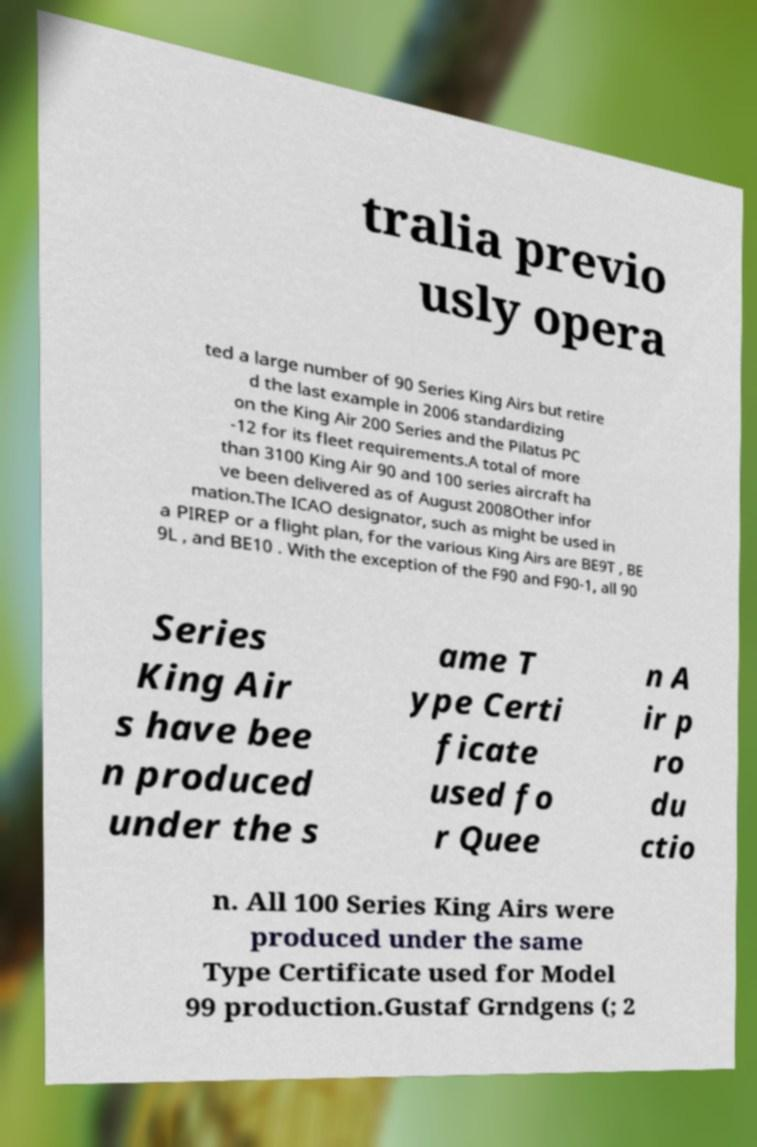I need the written content from this picture converted into text. Can you do that? tralia previo usly opera ted a large number of 90 Series King Airs but retire d the last example in 2006 standardizing on the King Air 200 Series and the Pilatus PC -12 for its fleet requirements.A total of more than 3100 King Air 90 and 100 series aircraft ha ve been delivered as of August 2008Other infor mation.The ICAO designator, such as might be used in a PIREP or a flight plan, for the various King Airs are BE9T , BE 9L , and BE10 . With the exception of the F90 and F90-1, all 90 Series King Air s have bee n produced under the s ame T ype Certi ficate used fo r Quee n A ir p ro du ctio n. All 100 Series King Airs were produced under the same Type Certificate used for Model 99 production.Gustaf Grndgens (; 2 